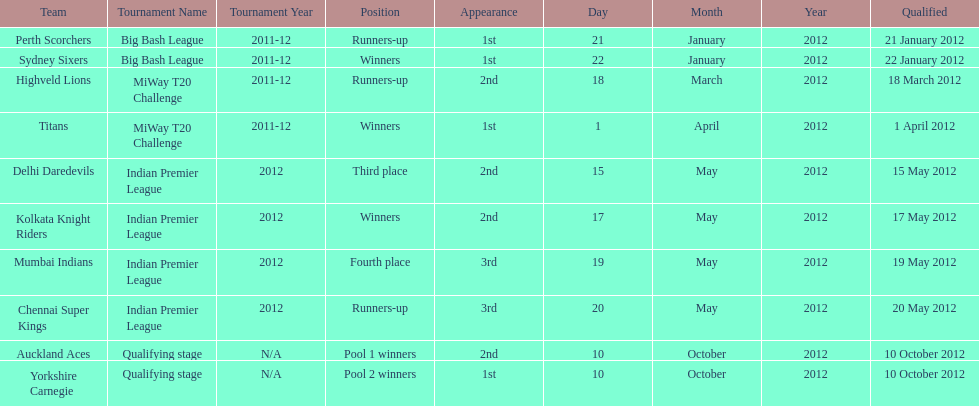Which team made their first appearance in the same tournament as the perth scorchers? Sydney Sixers. 